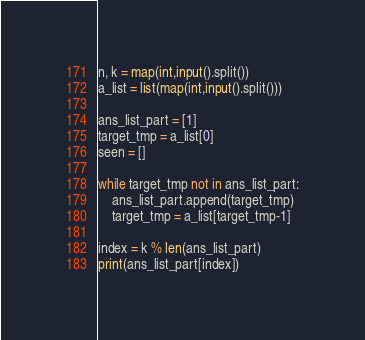<code> <loc_0><loc_0><loc_500><loc_500><_Python_>n, k = map(int,input().split())
a_list = list(map(int,input().split()))

ans_list_part = [1]
target_tmp = a_list[0]
seen = []

while target_tmp not in ans_list_part:
    ans_list_part.append(target_tmp)
    target_tmp = a_list[target_tmp-1]

index = k % len(ans_list_part)
print(ans_list_part[index])</code> 